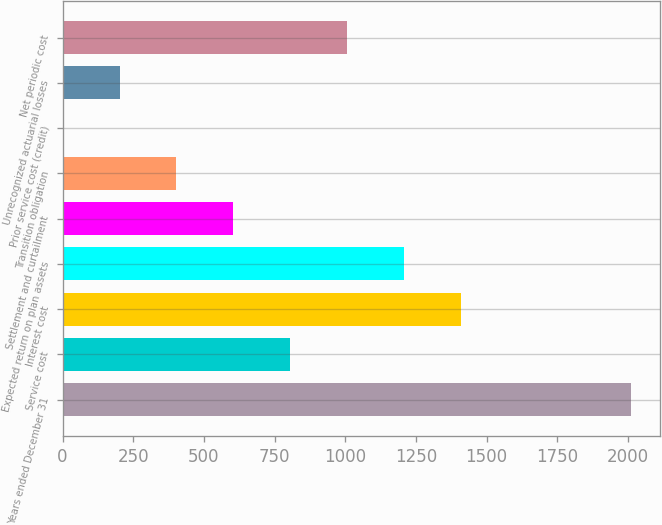Convert chart. <chart><loc_0><loc_0><loc_500><loc_500><bar_chart><fcel>Years ended December 31<fcel>Service cost<fcel>Interest cost<fcel>Expected return on plan assets<fcel>Settlement and curtailment<fcel>Transition obligation<fcel>Prior service cost (credit)<fcel>Unrecognized actuarial losses<fcel>Net periodic cost<nl><fcel>2011<fcel>804.52<fcel>1407.76<fcel>1206.68<fcel>603.44<fcel>402.36<fcel>0.2<fcel>201.28<fcel>1005.6<nl></chart> 